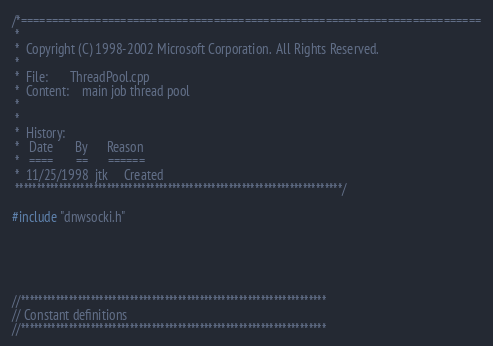Convert code to text. <code><loc_0><loc_0><loc_500><loc_500><_C++_>/*==========================================================================
 *
 *  Copyright (C) 1998-2002 Microsoft Corporation.  All Rights Reserved.
 *
 *  File:		ThreadPool.cpp
 *  Content:	main job thread pool
 *
 *
 *  History:
 *   Date		By		Reason
 *   ====		==		======
 *	11/25/1998	jtk		Created
 ***************************************************************************/

#include "dnwsocki.h"





//**********************************************************************
// Constant definitions
//**********************************************************************
</code> 